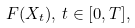Convert formula to latex. <formula><loc_0><loc_0><loc_500><loc_500>F ( X _ { t } ) , \, t \in [ 0 , T ] ,</formula> 